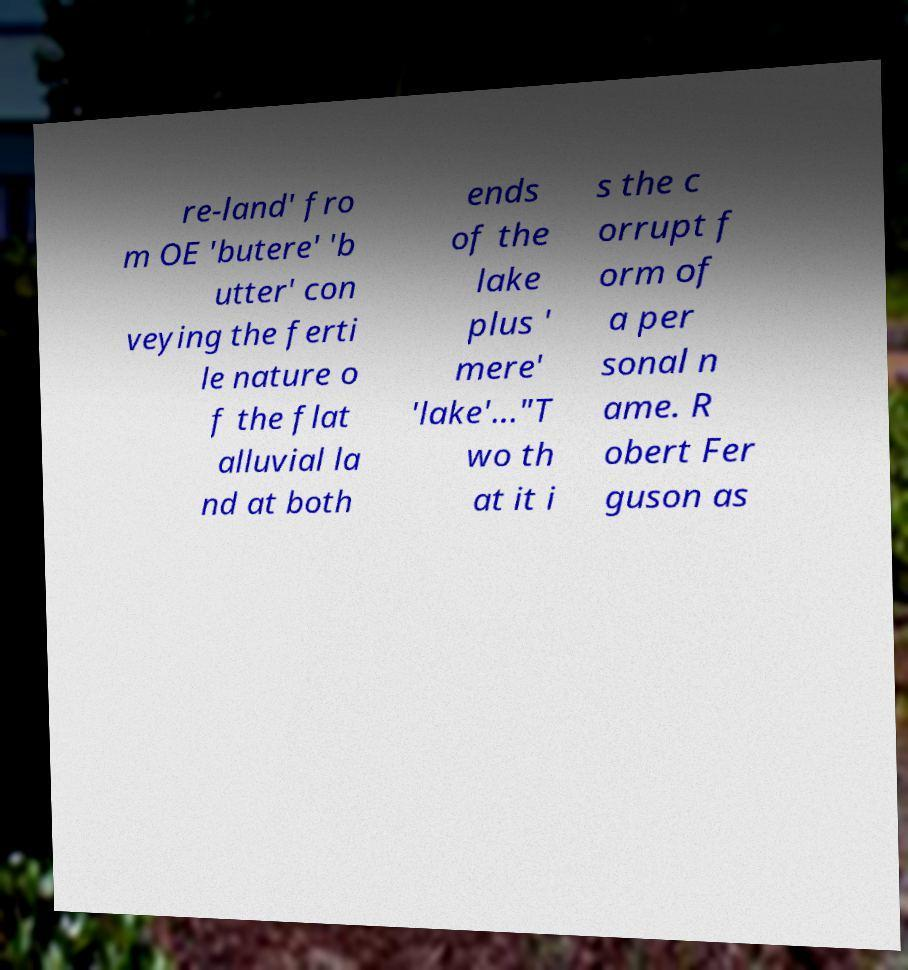Could you extract and type out the text from this image? re-land' fro m OE 'butere' 'b utter' con veying the ferti le nature o f the flat alluvial la nd at both ends of the lake plus ' mere' 'lake'..."T wo th at it i s the c orrupt f orm of a per sonal n ame. R obert Fer guson as 